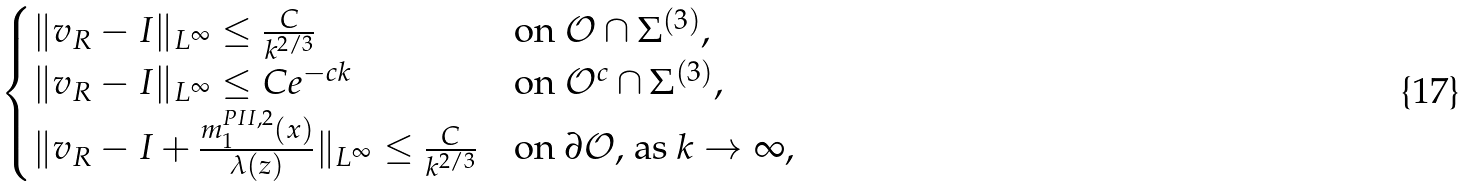<formula> <loc_0><loc_0><loc_500><loc_500>\begin{cases} \| v _ { R } - I \| _ { L ^ { \infty } } \leq \frac { C } { k ^ { 2 / 3 } } & \text {on $\mathcal{O} \cap \Sigma^{(3)}$} , \\ \| v _ { R } - I \| _ { L ^ { \infty } } \leq C e ^ { - c k } & \text {on $\mathcal{O}^{c} \cap \Sigma^{(3)}$} , \\ \| v _ { R } - I + \frac { m ^ { P I I , 2 } _ { 1 } ( x ) } { \lambda ( z ) } \| _ { L ^ { \infty } } \leq \frac { C } { k ^ { 2 / 3 } } & \text {on $\partial \mathcal{O}$, as $k\to\infty$,} \end{cases}</formula> 